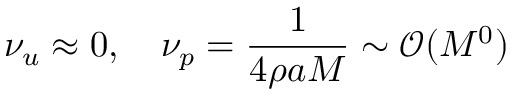<formula> <loc_0><loc_0><loc_500><loc_500>\nu _ { u } \approx 0 , \quad \nu _ { p } = \frac { 1 } { 4 \rho a M } \sim \mathcal { O } ( M ^ { 0 } )</formula> 